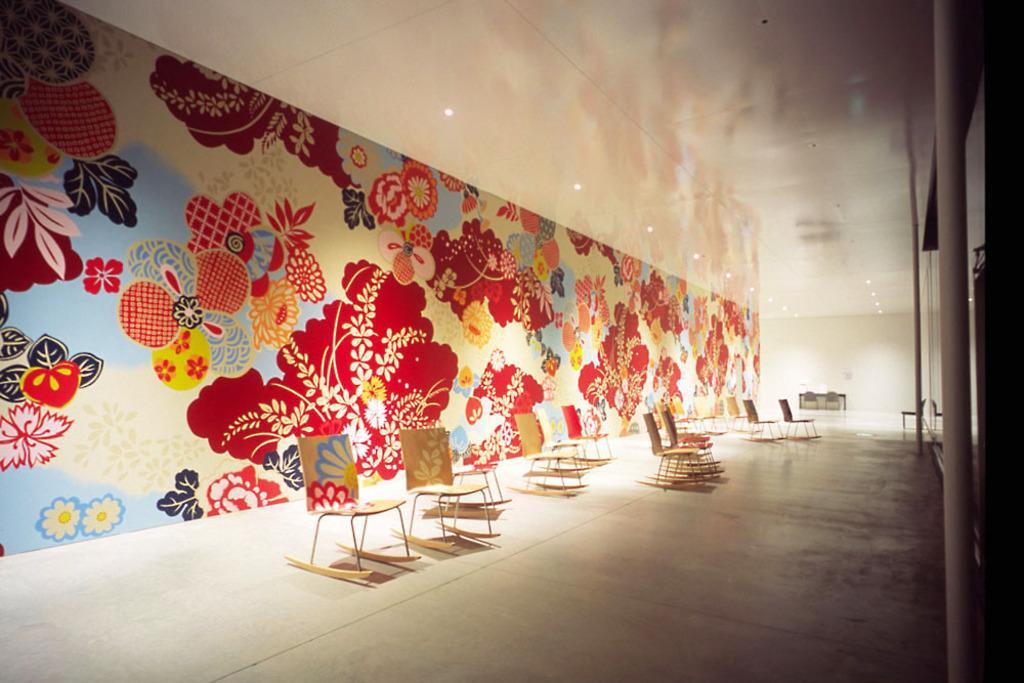Describe this image in one or two sentences. In this picture I can see in the middle there are chairs, in the background there are paintings on the wall. At the top there are ceiling lights. 